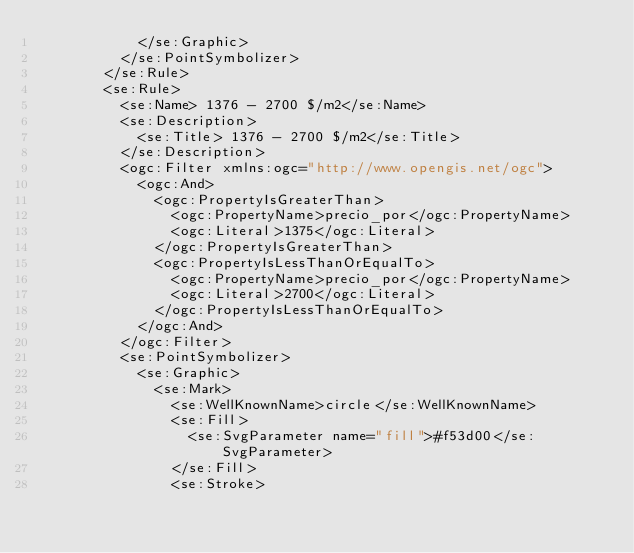<code> <loc_0><loc_0><loc_500><loc_500><_Scheme_>            </se:Graphic>
          </se:PointSymbolizer>
        </se:Rule>
        <se:Rule>
          <se:Name> 1376 - 2700 $/m2</se:Name>
          <se:Description>
            <se:Title> 1376 - 2700 $/m2</se:Title>
          </se:Description>
          <ogc:Filter xmlns:ogc="http://www.opengis.net/ogc">
            <ogc:And>
              <ogc:PropertyIsGreaterThan>
                <ogc:PropertyName>precio_por</ogc:PropertyName>
                <ogc:Literal>1375</ogc:Literal>
              </ogc:PropertyIsGreaterThan>
              <ogc:PropertyIsLessThanOrEqualTo>
                <ogc:PropertyName>precio_por</ogc:PropertyName>
                <ogc:Literal>2700</ogc:Literal>
              </ogc:PropertyIsLessThanOrEqualTo>
            </ogc:And>
          </ogc:Filter>
          <se:PointSymbolizer>
            <se:Graphic>
              <se:Mark>
                <se:WellKnownName>circle</se:WellKnownName>
                <se:Fill>
                  <se:SvgParameter name="fill">#f53d00</se:SvgParameter>
                </se:Fill>
                <se:Stroke></code> 